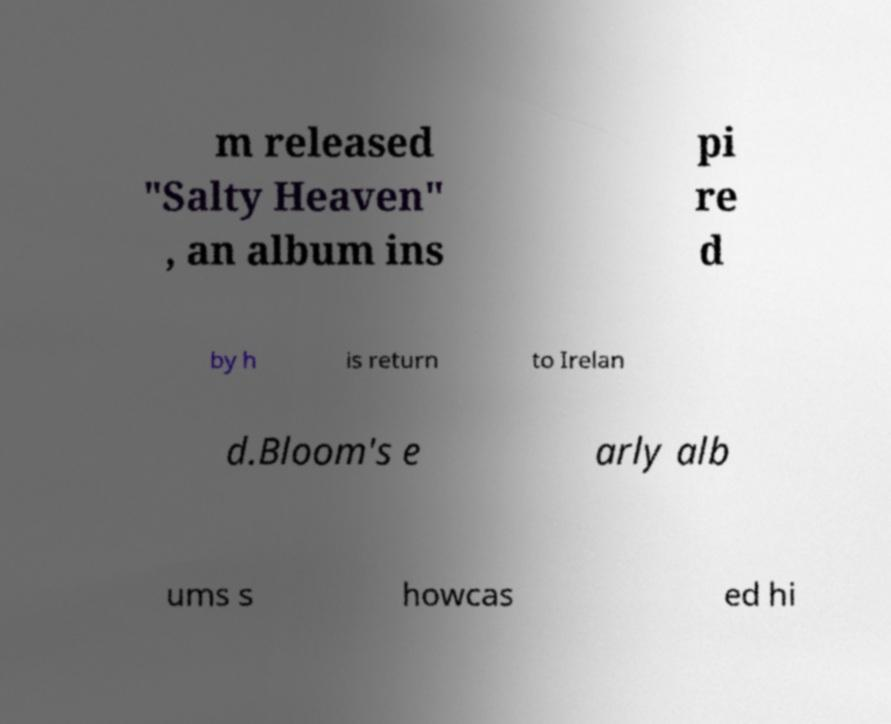Please read and relay the text visible in this image. What does it say? m released "Salty Heaven" , an album ins pi re d by h is return to Irelan d.Bloom's e arly alb ums s howcas ed hi 